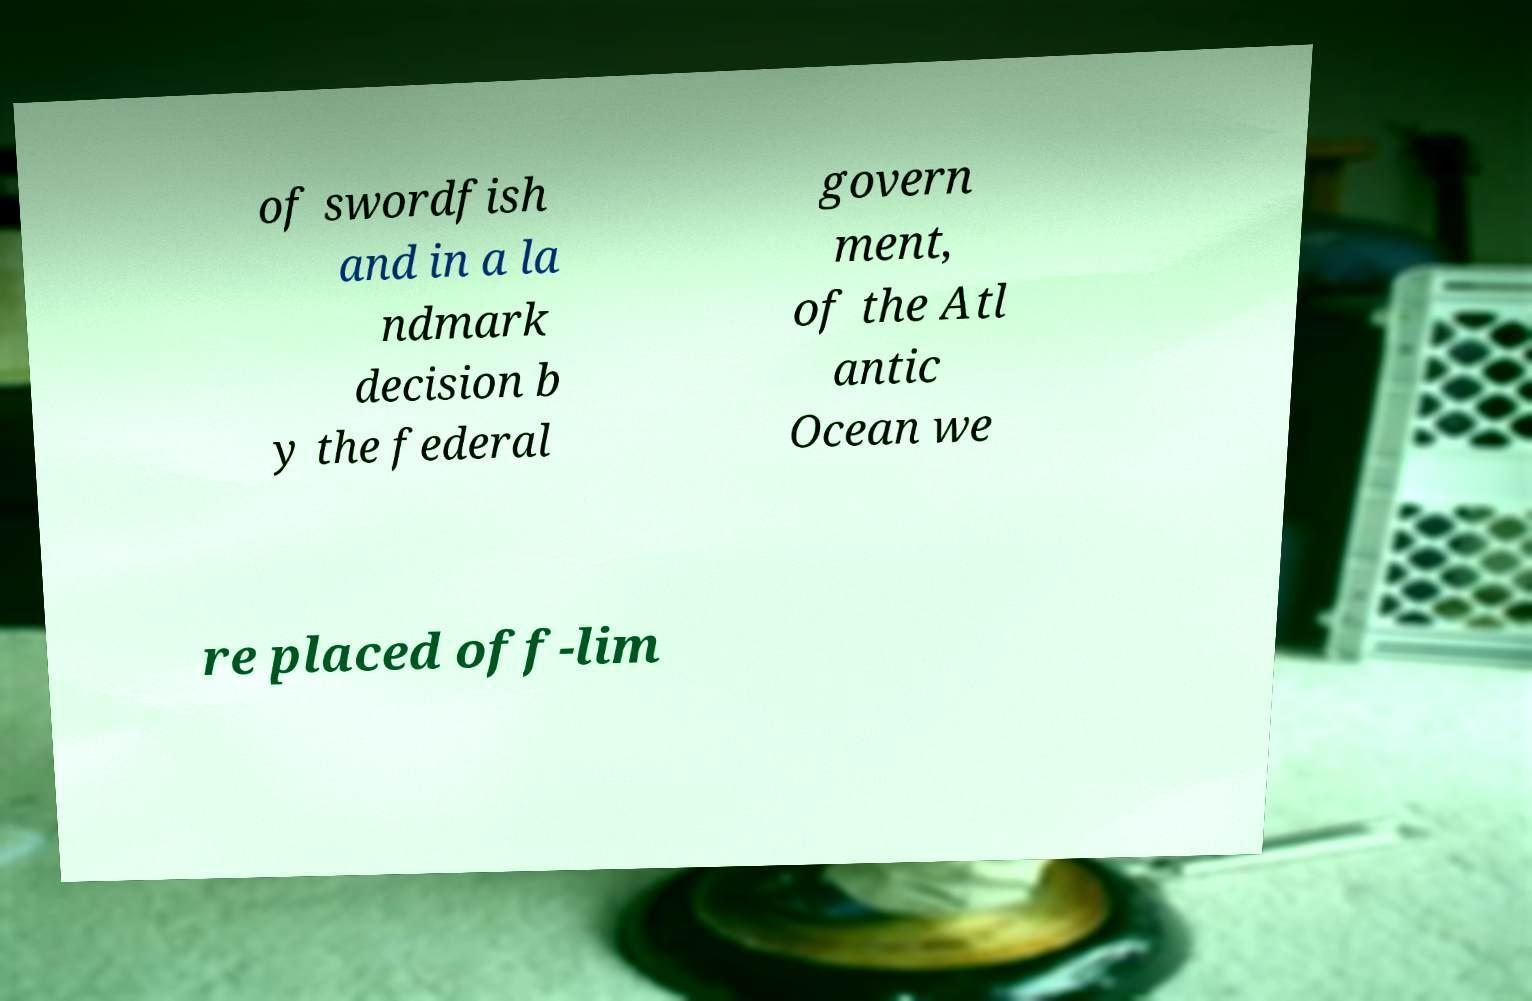Can you accurately transcribe the text from the provided image for me? of swordfish and in a la ndmark decision b y the federal govern ment, of the Atl antic Ocean we re placed off-lim 